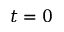<formula> <loc_0><loc_0><loc_500><loc_500>t = 0</formula> 